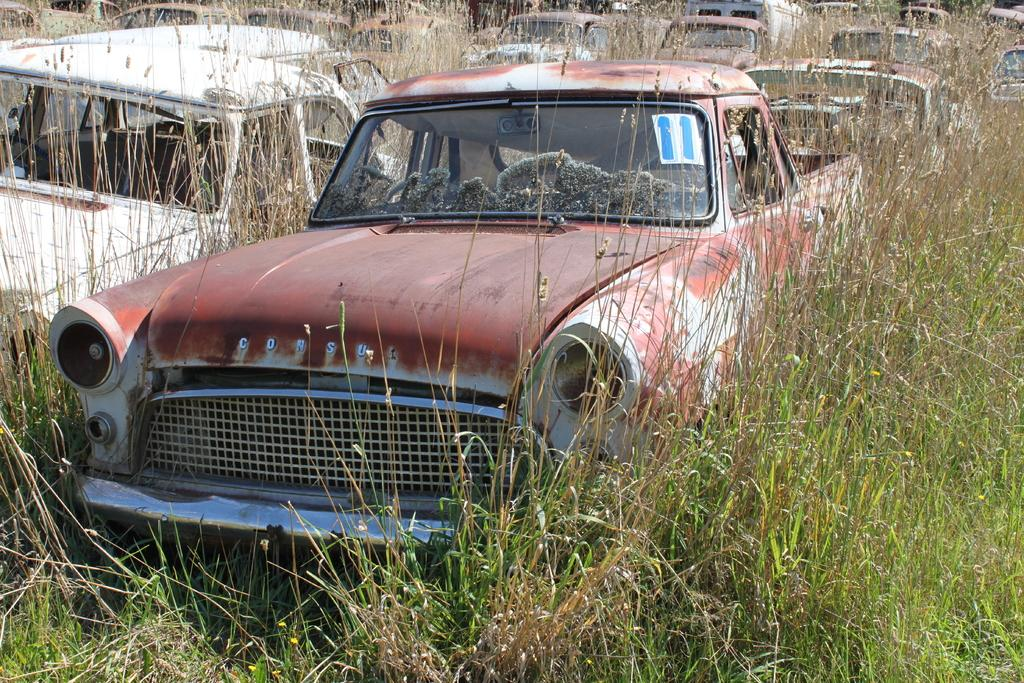What can be seen in the image related to transportation? There is a group of vehicles in the image. What type of natural environment is visible in the image? There is grass visible in the image. Can you describe any additional details about one of the cars? There is a paper on one of the cars, and it has a number on it. Where can the honey be found in the image? There is no honey present in the image. What type of ticket is visible on the car? The paper on the car does not appear to be a ticket; it has a number on it. 